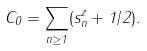<formula> <loc_0><loc_0><loc_500><loc_500>C _ { 0 } = \sum _ { n \geq 1 } ( s ^ { z } _ { n } + 1 / 2 ) .</formula> 